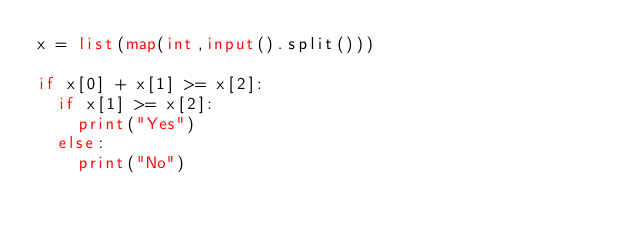<code> <loc_0><loc_0><loc_500><loc_500><_Python_>x = list(map(int,input().split()))

if x[0] + x[1] >= x[2]:
  if x[1] >= x[2]:
    print("Yes")
  else:
    print("No")
  </code> 